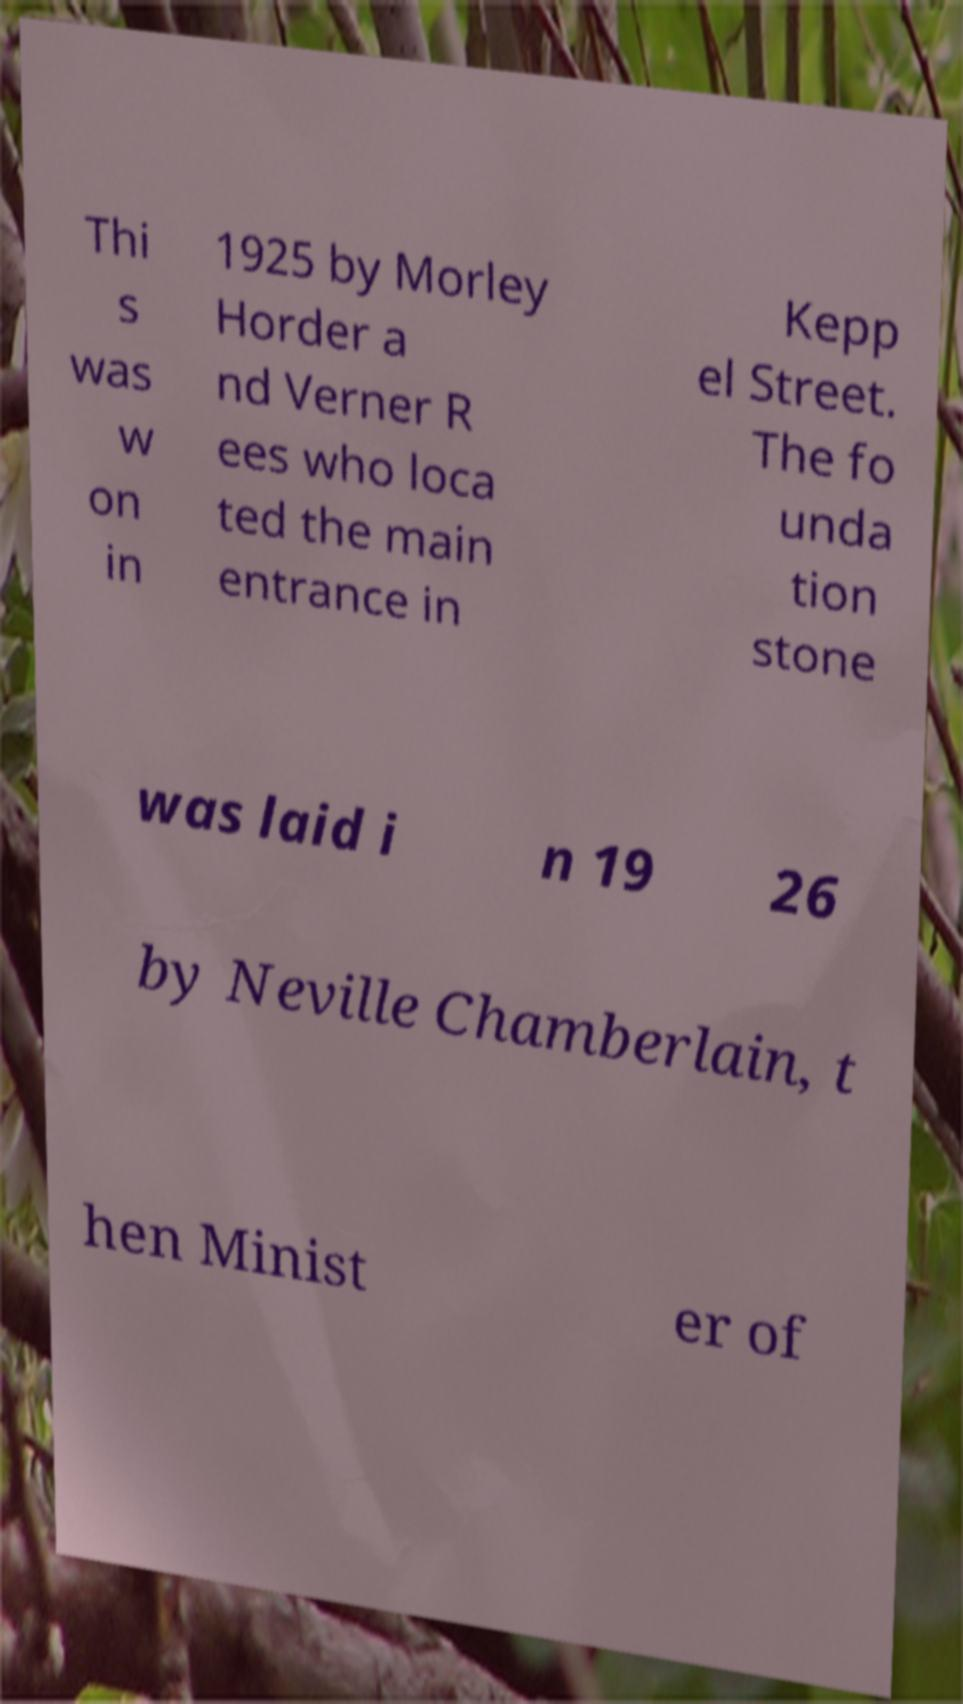There's text embedded in this image that I need extracted. Can you transcribe it verbatim? Thi s was w on in 1925 by Morley Horder a nd Verner R ees who loca ted the main entrance in Kepp el Street. The fo unda tion stone was laid i n 19 26 by Neville Chamberlain, t hen Minist er of 